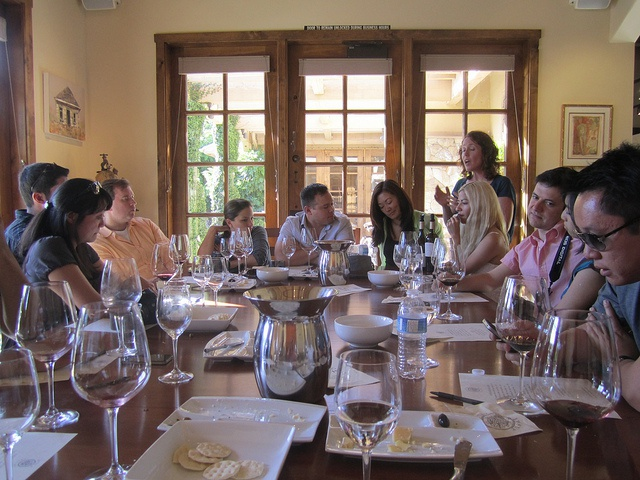Describe the objects in this image and their specific colors. I can see dining table in black, gray, and darkgray tones, people in black and gray tones, wine glass in black, gray, and purple tones, wine glass in black, gray, and darkgray tones, and wine glass in black and gray tones in this image. 